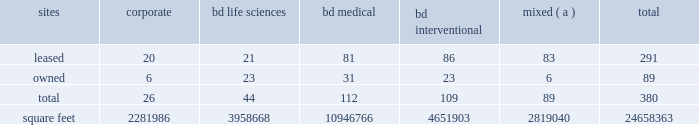Agreements containing cross-default provisions .
Under these circumstances , we might not have sufficient funds or other resources to satisfy all of our obligations .
The mandatory convertible preferred stock underlying the depositary shares issued in connection with the financing of the bard transaction may adversely affect the market price of bd common stock .
The market price of bd common stock is likely to be influenced by the mandatory convertible preferred stock underlying the depositary shares issued in connection with the financing for the bard transaction .
The market price of bd common stock could become more volatile and could be depressed by : 2022 investors 2019 anticipation of the potential resale in the market of a substantial number of additional shares of bd common stock received upon conversion of the mandatory convertible preferred stock ; 2022 possible sales of bd common stock by investors who view the mandatory convertible preferred stock as a more attractive means of equity participation in bd than owning shares of bd common stock ; and 2022 hedging or arbitrage trading activity that may develop involving the mandatory convertible preferred stock and bd common stock .
Item 1b .
Unresolved staff comments .
Item 2 .
Properties .
Bd 2019s executive offices are located in franklin lakes , new jersey .
As of october 31 , 2018 , bd owned or leased 380 facilities throughout the world , comprising approximately 24658363 square feet of manufacturing , warehousing , administrative and research facilities .
The u.s .
Facilities , including those in puerto rico , comprise approximately 8619099 square feet of owned and 4407539 square feet of leased space .
The international facilities comprise approximately 8484223 square feet of owned and 3147502 square feet of leased space .
Sales offices and distribution centers included in the total square footage are also located throughout the world .
Operations in each of bd 2019s business segments are conducted at both u.s .
And international locations .
Particularly in the international marketplace , facilities often serve more than one business segment and are used for multiple purposes , such as administrative/sales , manufacturing and/or warehousing/distribution .
Bd generally seeks to own its manufacturing facilities , although some are leased .
The table summarizes property information by business segment. .
( a ) facilities used by more than one business segment .
Bd believes that its facilities are of good construction and in good physical condition , are suitable and adequate for the operations conducted at those facilities , and are , with minor exceptions , fully utilized and operating at normal capacity .
The u.s .
Facilities are located in alabama , arizona , california , connecticut , florida , georgia , illinois , indiana , maryland , massachusetts , michigan , minnesota , missouri , montana , nebraska , new jersey , new york , north carolina , ohio , oklahoma , oregon , pennsylvania , rhode island , south carolina , tennessee , texas , utah , virginia , washington , d.c. , washington , wisconsin and puerto rico. .
What is the average square footage of leased corporate sites? 
Computations: (2281986 / 20)
Answer: 114099.3. 